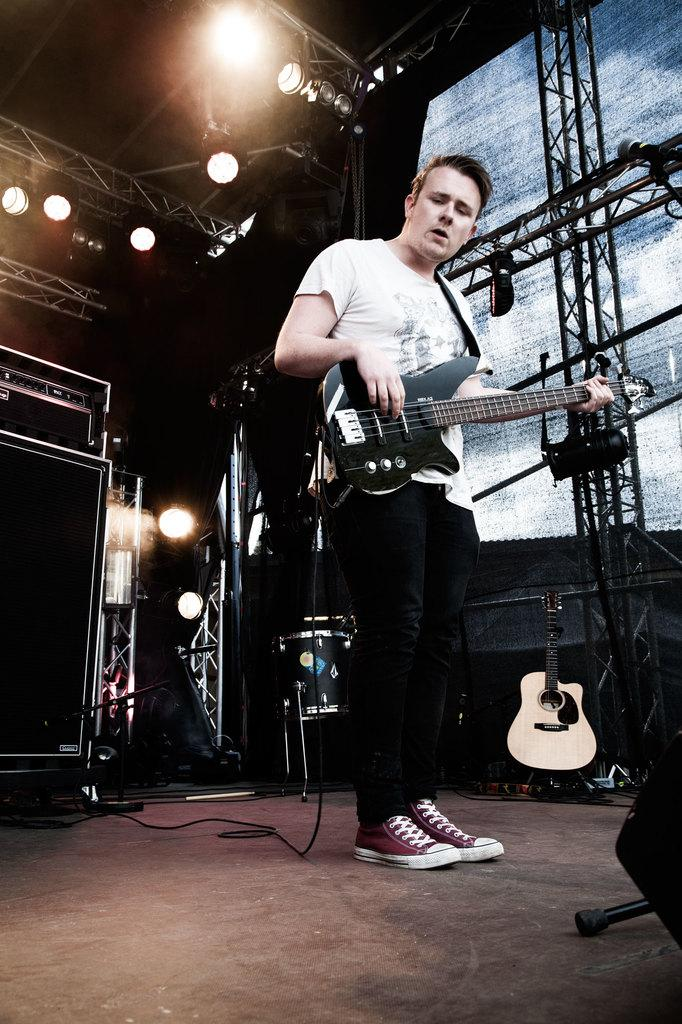What is the main activity of the person in the image? There is a guy playing guitar in the image. Where is the guy playing guitar located? The guy is on a stage. What can be seen on the ceiling in the image? There are many lights on the ceiling in the image. How many goldfish are swimming in the guitar strings in the image? There are no goldfish present in the image, and they are not swimming in the guitar strings. 